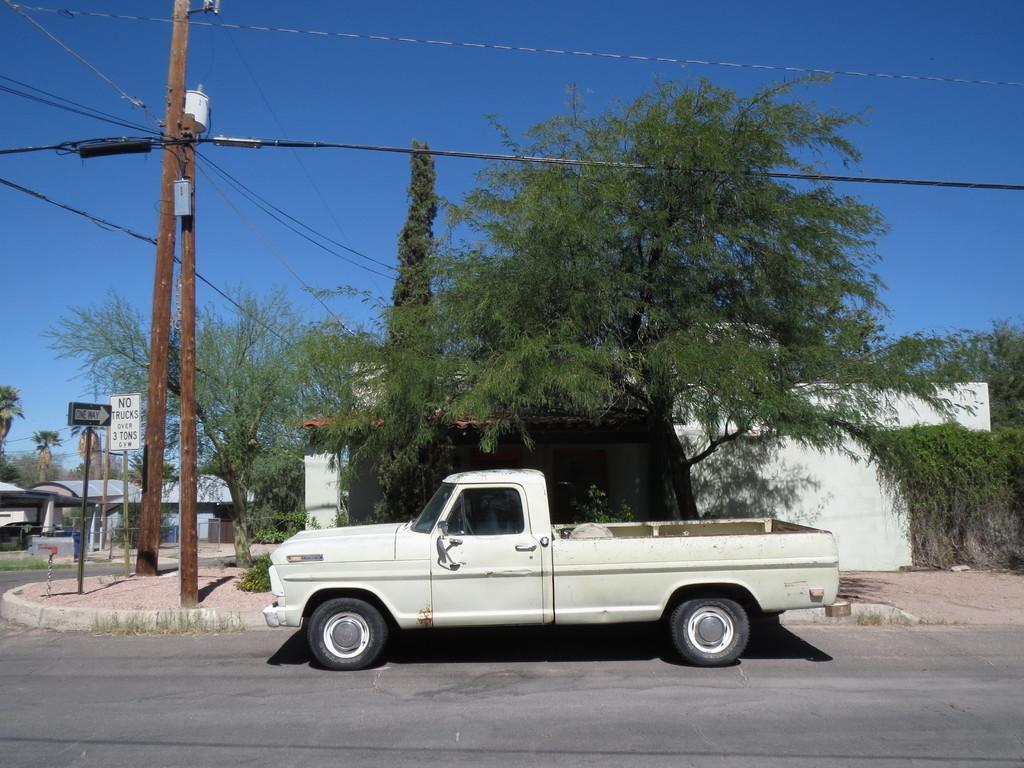Describe this image in one or two sentences. In this image I can see the vehicle on the road. To the side of the road I can see boards and poles. On both sides of the road I can see many trees and buildings. In the background I can see the sky. 